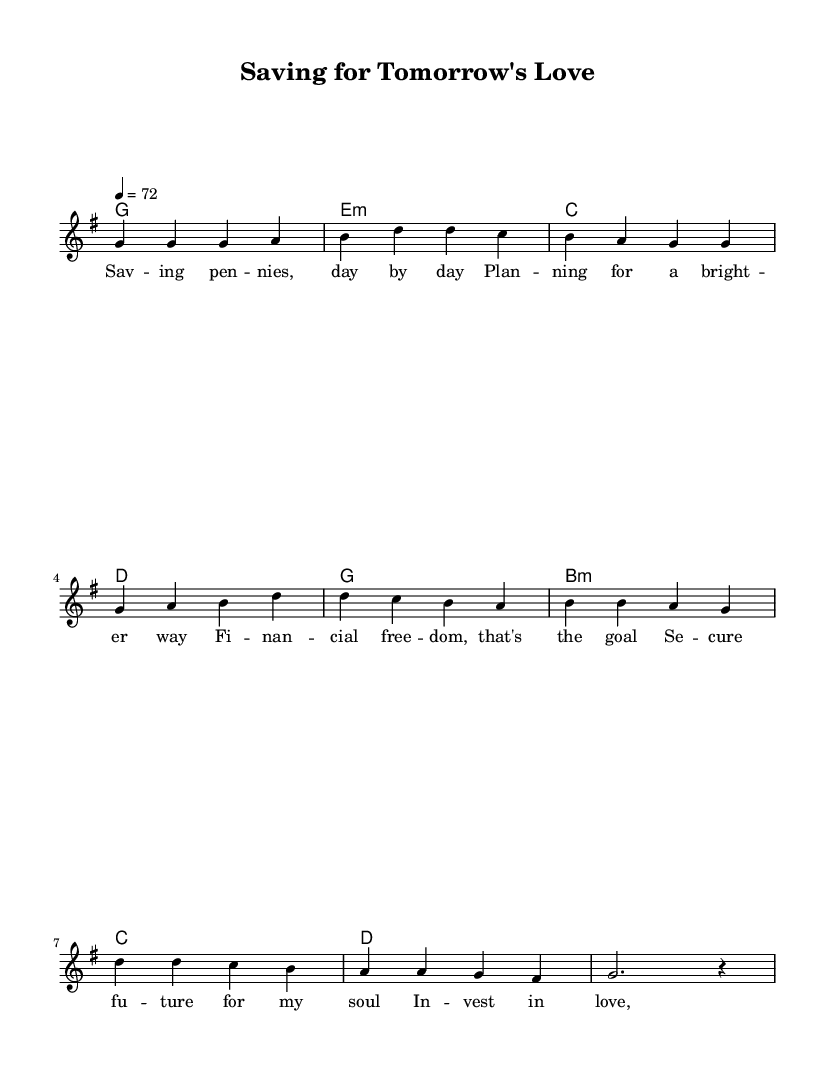What is the key signature of this music? The key signature is G major, which has one sharp (F#). This can be identified by looking at the beginning of the staff where sharps or flats are noted.
Answer: G major What is the time signature of this music? The time signature is 4/4, which can be recognized by the two numbers at the beginning of the staff. The top number indicates 4 beats per measure, and the bottom number signifies that a quarter note receives one beat.
Answer: 4/4 What is the tempo marking in this music? The tempo marking is 72 beats per minute, indicated by the number following "tempo." This suggests a moderate pace for the performance.
Answer: 72 How many measures are in the verse section? The verse section contains 4 measures, which can be counted from the notation provided for the melody and harmonies. Each line in the melody corresponds to a distinct measure in the music.
Answer: 4 What is the primary theme expressed in the lyrics of the chorus? The primary theme in the chorus revolves around financial investment and planning for a better future. This is derived from analyzing the words presented in the lyric mode of the chorus, capturing the essence of the song's message regarding financial responsibility.
Answer: Investment What chord is used at the end of the chorus? The chord at the end of the chorus is D major, which can be seen in the chord mode section where the last harmony indicated corresponds to this chord type.
Answer: D How many stanzas are in the entire piece? The entire piece contains two stanzas, one being the verse and the other being the chorus. This can be deduced from the layout of the score, where each section is labeled and the lyrics are divided accordingly.
Answer: 2 